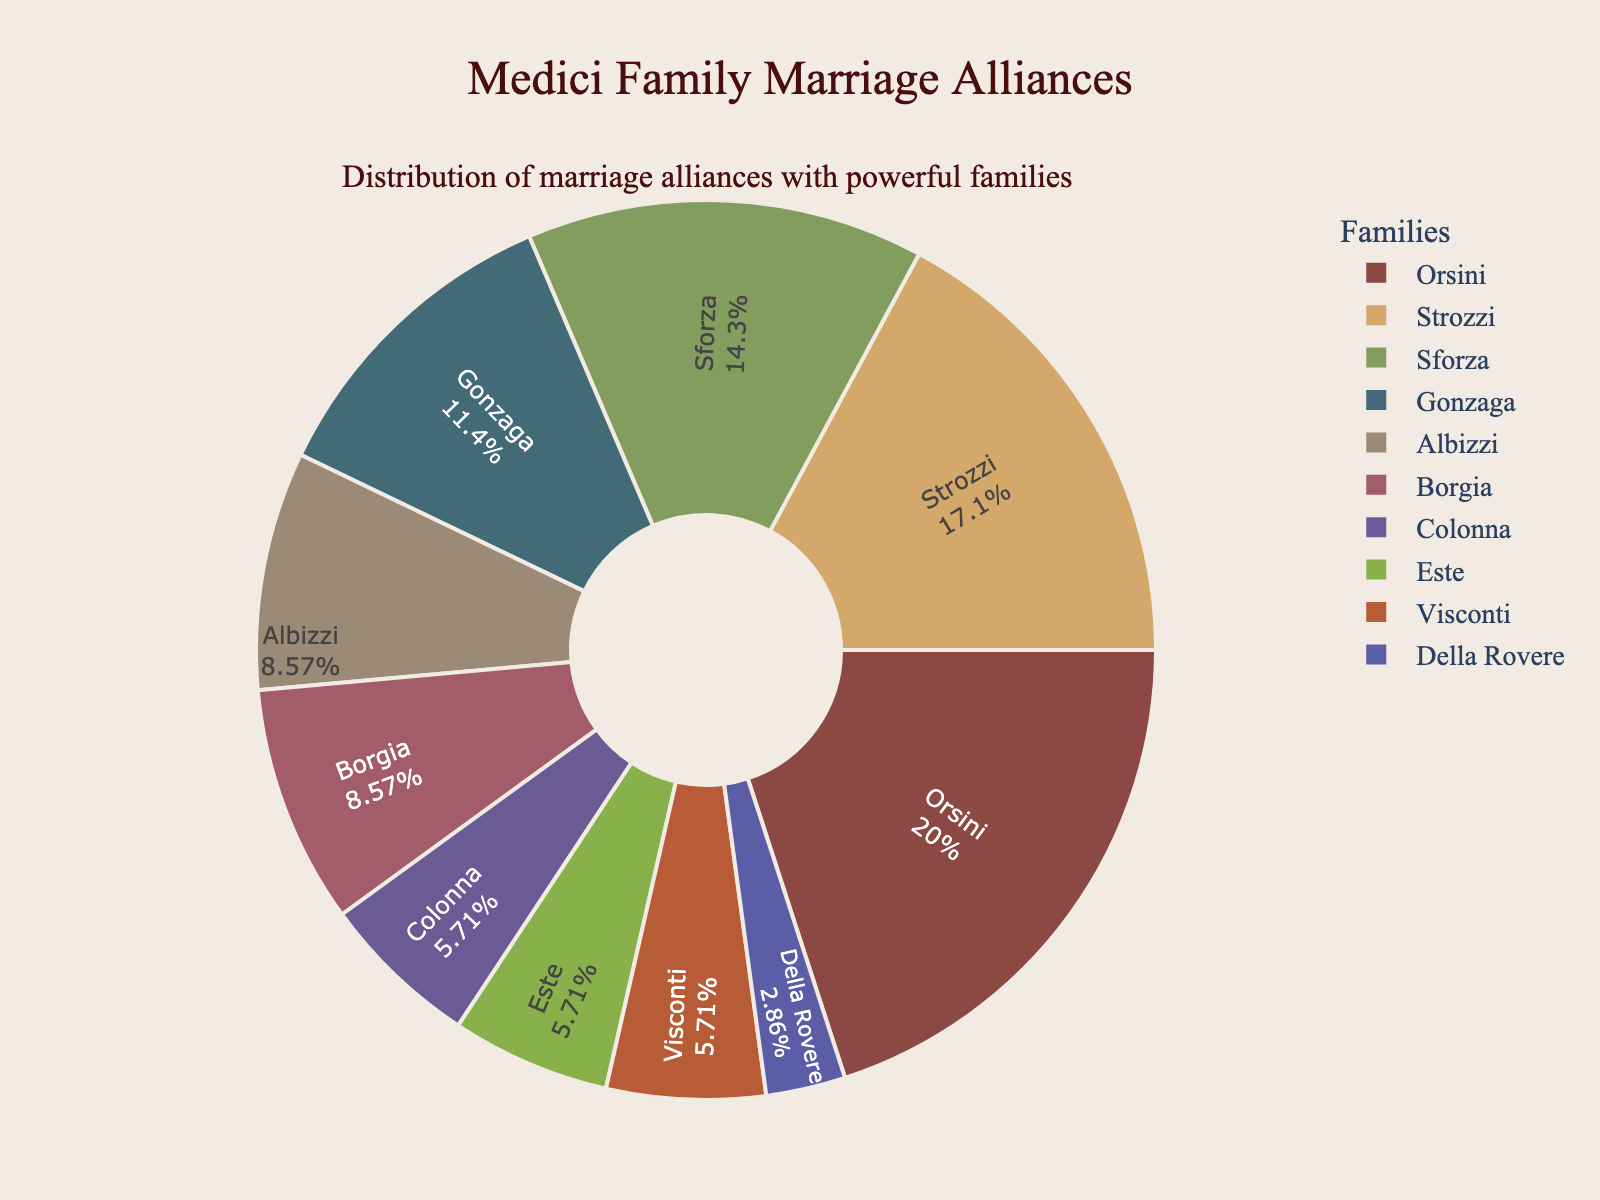What percentage of the Medici family marriage alliances were formed with the Orsini family? The Orsini family is labeled with its percentage on the pie chart. By looking at the section labeled "Orsini," we can see the exact percentage.
Answer: 21.2% Which family formed the least number of alliances with the Medici family? The family with the smallest section in the pie chart would have formed the least number of alliances. The "Della Rovere" section should be the smallest, indicating it formed the least number of alliances.
Answer: Della Rovere How many more alliances did the Medici form with the Strozzi family than with the Este family? First, locate the values for Strozzi and Este. Strozzi has 6 alliances and Este has 2. Subtract the Este value from the Strozzi value: 6 - 2 = 4.
Answer: 4 What is the sum of the alliances formed with the Orsini and Sforza families? Identify the number of alliances for Orsini (7) and Sforza (5), then add these values: 7 + 5 = 12.
Answer: 12 Which family's section is colored in green? By observing the color of each section, the green color corresponds to a specific family. In this pie chart, the green section corresponds to the "Gonzaga" family.
Answer: Gonzaga Are there more alliances with the Colonna family or the Visconti family? Check the sections for Colonna and Visconti in the pie chart. Both Colonna and Visconti have the same number of alliances, which is indicated by the equal size of their sections.
Answer: Equal What is the combined percentage of alliances formed with the Strozzi and Gonzaga families? Determine the percentage for Strozzi and Gonzaga from the pie chart, then add these values. If Strozzi has around 18.2% and Gonzaga has around 12.1%, the sum is about 18.2% + 12.1% = 30.3%.
Answer: 30.3% Which two families have exactly the same number of alliances with the Medici family? Check for sections of equal size. The pie chart shows that the Albizzi and Borgia families both have 3 alliances.
Answer: Albizzi and Borgia How many families formed fewer than 3 alliances with the Medici family? Identify sections that represent fewer than 3 alliances. The families are Colonna, Este, Visconti, and Della Rovere. Count these families to get the total.
Answer: 4 What is the difference in the number of alliances between the family with the most alliances and the family with the second most alliances? The Orsini family has the most alliances with 7. The Strozzi comes next with 6. Subtract the Strozzi value from the Orsini value: 7 - 6 = 1.
Answer: 1 